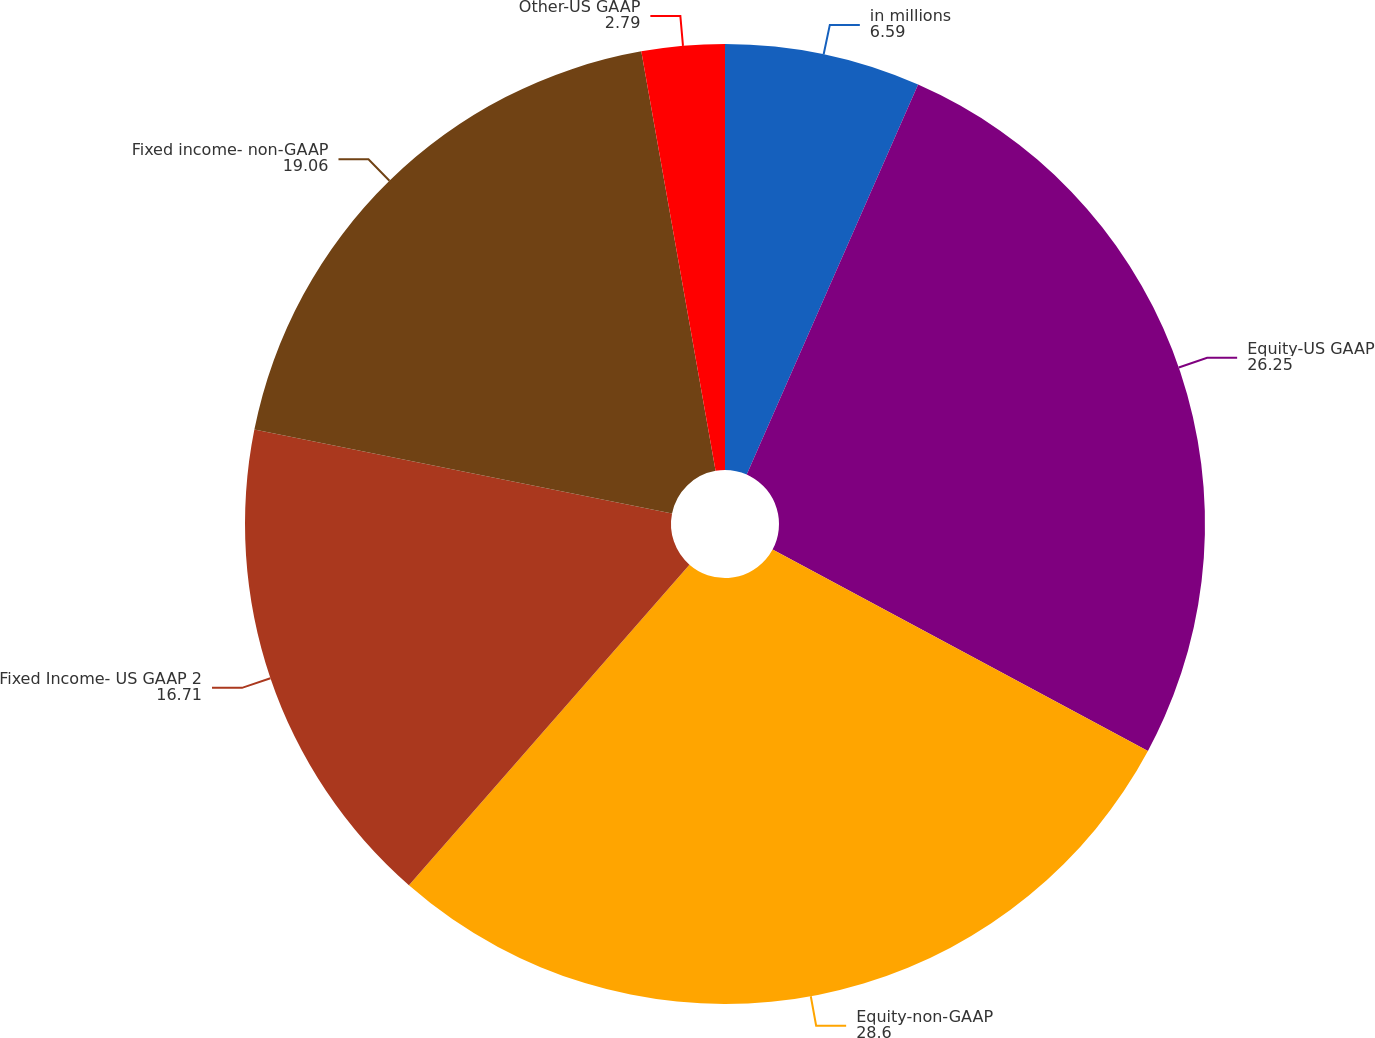Convert chart. <chart><loc_0><loc_0><loc_500><loc_500><pie_chart><fcel>in millions<fcel>Equity-US GAAP<fcel>Equity-non-GAAP<fcel>Fixed Income- US GAAP 2<fcel>Fixed income- non-GAAP<fcel>Other-US GAAP<nl><fcel>6.59%<fcel>26.25%<fcel>28.6%<fcel>16.71%<fcel>19.06%<fcel>2.79%<nl></chart> 